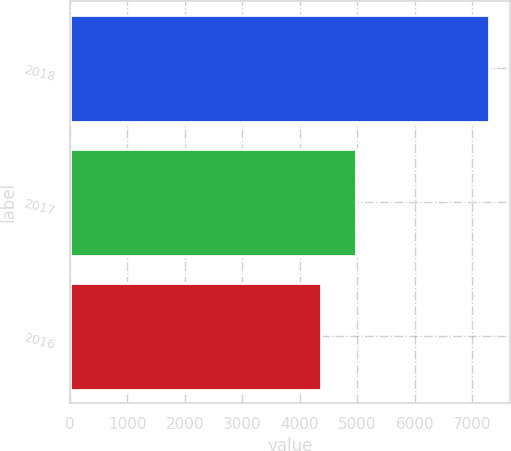<chart> <loc_0><loc_0><loc_500><loc_500><bar_chart><fcel>2018<fcel>2017<fcel>2016<nl><fcel>7290<fcel>4973<fcel>4371<nl></chart> 